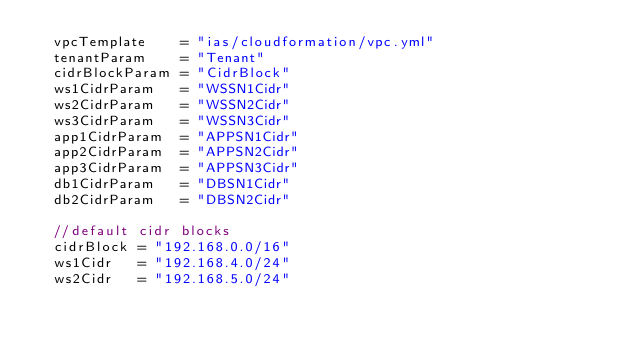Convert code to text. <code><loc_0><loc_0><loc_500><loc_500><_Go_>	vpcTemplate    = "ias/cloudformation/vpc.yml"
	tenantParam    = "Tenant"
	cidrBlockParam = "CidrBlock"
	ws1CidrParam   = "WSSN1Cidr"
	ws2CidrParam   = "WSSN2Cidr"
	ws3CidrParam   = "WSSN3Cidr"
	app1CidrParam  = "APPSN1Cidr"
	app2CidrParam  = "APPSN2Cidr"
	app3CidrParam  = "APPSN3Cidr"
	db1CidrParam   = "DBSN1Cidr"
	db2CidrParam   = "DBSN2Cidr"

	//default cidr blocks
	cidrBlock = "192.168.0.0/16"
	ws1Cidr   = "192.168.4.0/24"
	ws2Cidr   = "192.168.5.0/24"</code> 